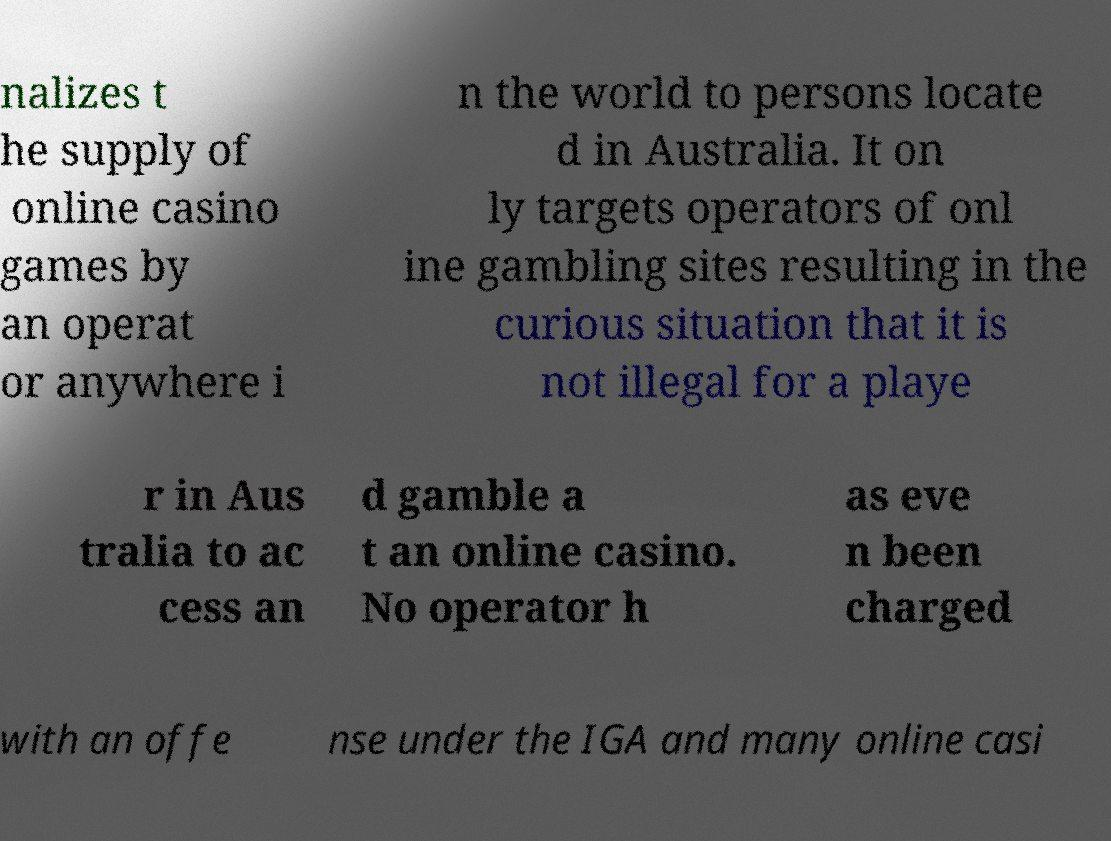There's text embedded in this image that I need extracted. Can you transcribe it verbatim? nalizes t he supply of online casino games by an operat or anywhere i n the world to persons locate d in Australia. It on ly targets operators of onl ine gambling sites resulting in the curious situation that it is not illegal for a playe r in Aus tralia to ac cess an d gamble a t an online casino. No operator h as eve n been charged with an offe nse under the IGA and many online casi 